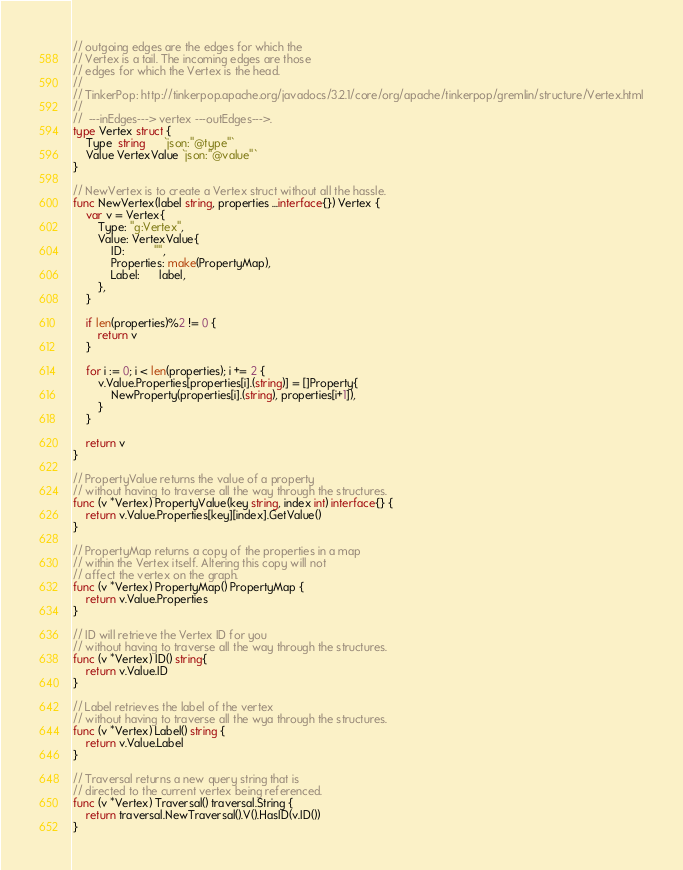<code> <loc_0><loc_0><loc_500><loc_500><_Go_>// outgoing edges are the edges for which the
// Vertex is a tail. The incoming edges are those
// edges for which the Vertex is the head.
//
// TinkerPop: http://tinkerpop.apache.org/javadocs/3.2.1/core/org/apache/tinkerpop/gremlin/structure/Vertex.html
//
//  ---inEdges---> vertex ---outEdges--->.
type Vertex struct {
	Type  string      `json:"@type"`
	Value VertexValue `json:"@value"`
}

// NewVertex is to create a Vertex struct without all the hassle.
func NewVertex(label string, properties ...interface{}) Vertex {
	var v = Vertex{
		Type: "g:Vertex",
		Value: VertexValue{
			ID:         "",
			Properties: make(PropertyMap),
			Label:      label,
		},
	}

	if len(properties)%2 != 0 {
		return v
	}

	for i := 0; i < len(properties); i += 2 {
		v.Value.Properties[properties[i].(string)] = []Property{
			NewProperty(properties[i].(string), properties[i+1]),
		}
	}

	return v
}

// PropertyValue returns the value of a property
// without having to traverse all the way through the structures.
func (v *Vertex) PropertyValue(key string, index int) interface{} {
	return v.Value.Properties[key][index].GetValue()
}

// PropertyMap returns a copy of the properties in a map
// within the Vertex itself. Altering this copy will not
// affect the vertex on the graph.
func (v *Vertex) PropertyMap() PropertyMap {
	return v.Value.Properties
}

// ID will retrieve the Vertex ID for you
// without having to traverse all the way through the structures.
func (v *Vertex) ID() string{
	return v.Value.ID
}

// Label retrieves the label of the vertex
// without having to traverse all the wya through the structures.
func (v *Vertex) Label() string {
	return v.Value.Label
}

// Traversal returns a new query string that is
// directed to the current vertex being referenced.
func (v *Vertex) Traversal() traversal.String {
	return traversal.NewTraversal().V().HasID(v.ID())
}
</code> 